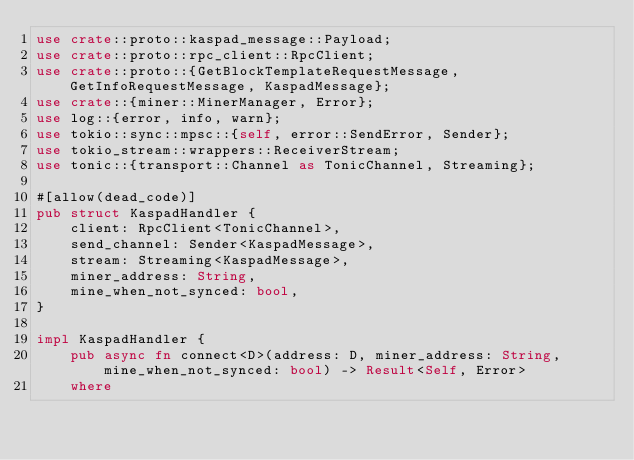<code> <loc_0><loc_0><loc_500><loc_500><_Rust_>use crate::proto::kaspad_message::Payload;
use crate::proto::rpc_client::RpcClient;
use crate::proto::{GetBlockTemplateRequestMessage, GetInfoRequestMessage, KaspadMessage};
use crate::{miner::MinerManager, Error};
use log::{error, info, warn};
use tokio::sync::mpsc::{self, error::SendError, Sender};
use tokio_stream::wrappers::ReceiverStream;
use tonic::{transport::Channel as TonicChannel, Streaming};

#[allow(dead_code)]
pub struct KaspadHandler {
    client: RpcClient<TonicChannel>,
    send_channel: Sender<KaspadMessage>,
    stream: Streaming<KaspadMessage>,
    miner_address: String,
    mine_when_not_synced: bool,
}

impl KaspadHandler {
    pub async fn connect<D>(address: D, miner_address: String, mine_when_not_synced: bool) -> Result<Self, Error>
    where</code> 